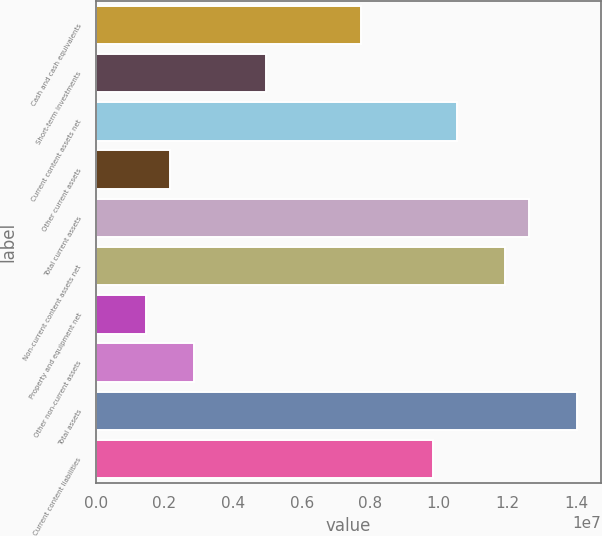<chart> <loc_0><loc_0><loc_500><loc_500><bar_chart><fcel>Cash and cash equivalents<fcel>Short-term investments<fcel>Current content assets net<fcel>Other current assets<fcel>Total current assets<fcel>Non-current content assets net<fcel>Property and equipment net<fcel>Other non-current assets<fcel>Total assets<fcel>Current content liabilities<nl><fcel>7.74075e+06<fcel>4.94774e+06<fcel>1.05338e+07<fcel>2.15472e+06<fcel>1.26285e+07<fcel>1.19303e+07<fcel>1.45647e+06<fcel>2.85297e+06<fcel>1.4025e+07<fcel>9.83552e+06<nl></chart> 